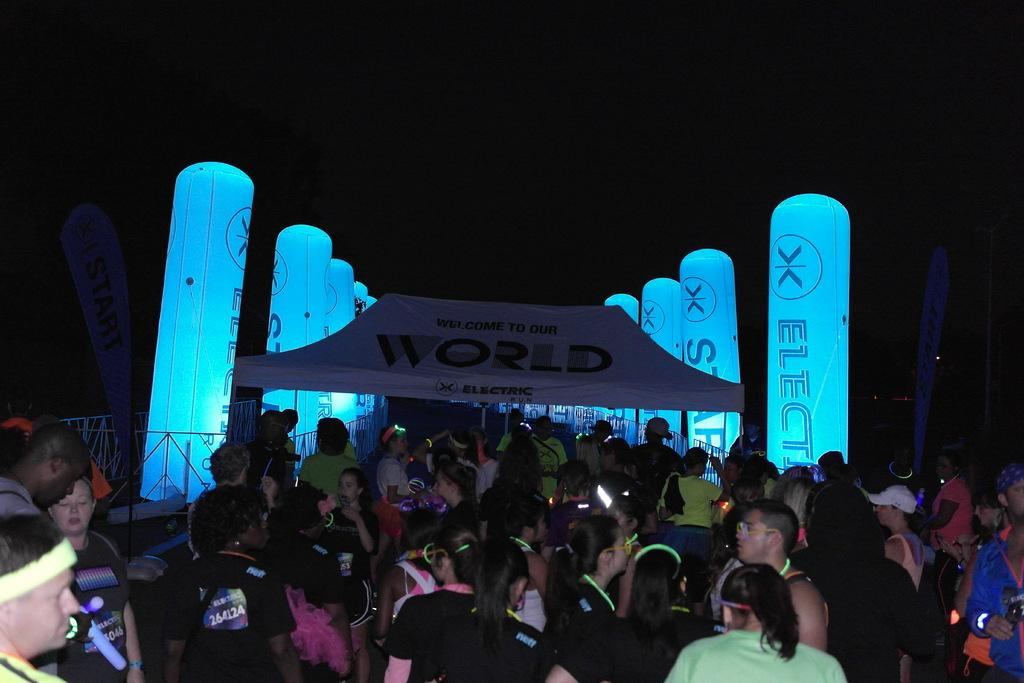How many people are present in the image? There are many persons standing on the ground in the image. What can be seen in the background of the image? There are balloons and plants in the background of the image. What is visible in the sky in the image? The sky is visible in the background of the image. Which actor is performing in the image? There is no actor or performance present in the image; it features a group of people standing on the ground with balloons and plants in the background. 